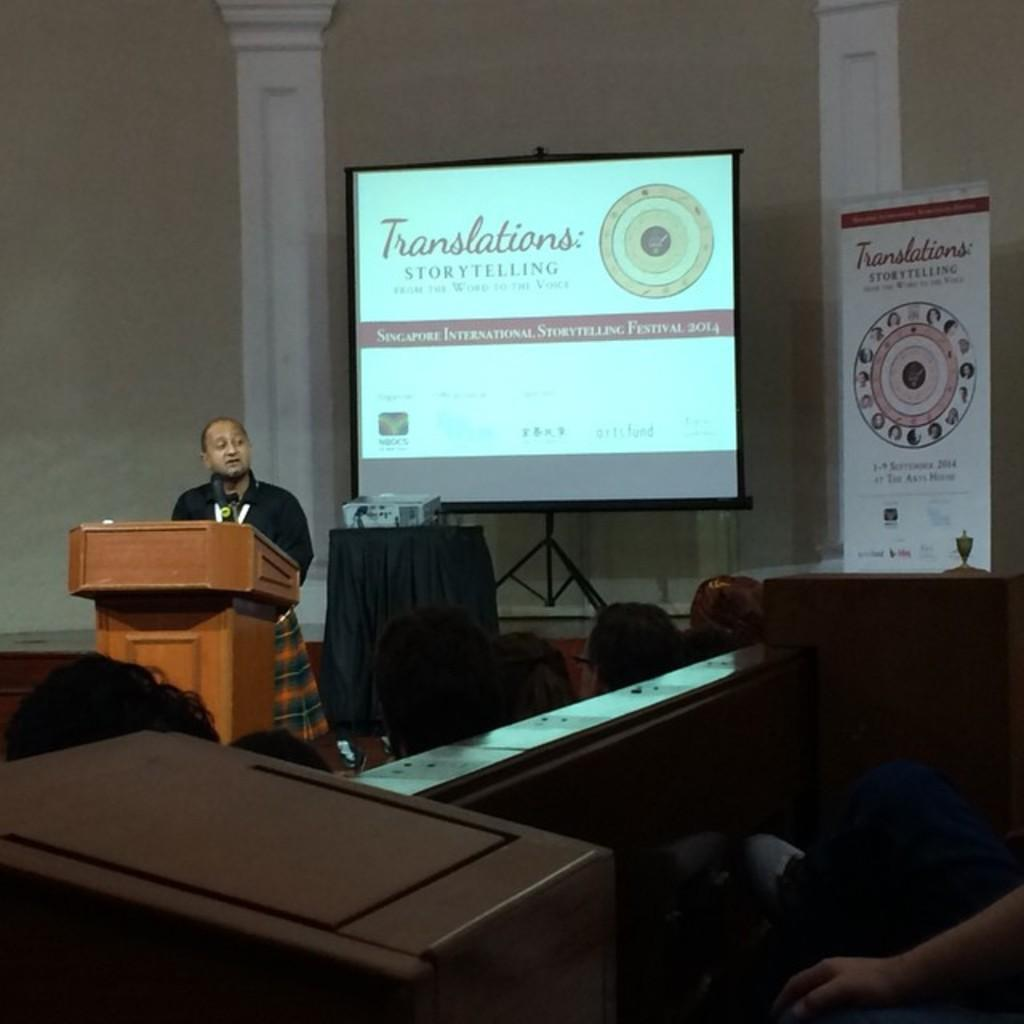What is the man in the image doing? The man is standing in front of a podium. Can you describe the people in the image? There are people in the image, but their specific actions or positions are not mentioned in the facts. What equipment is visible in the background of the image? There is a projector and a projector screen in the background. What type of salt is being used to brush the man's teeth in the image? There is no toothpaste or salt present in the image, and the man's teeth are not being brushed. What is the nature of the love depicted in the image? There is no mention of love or any romantic context in the image. 